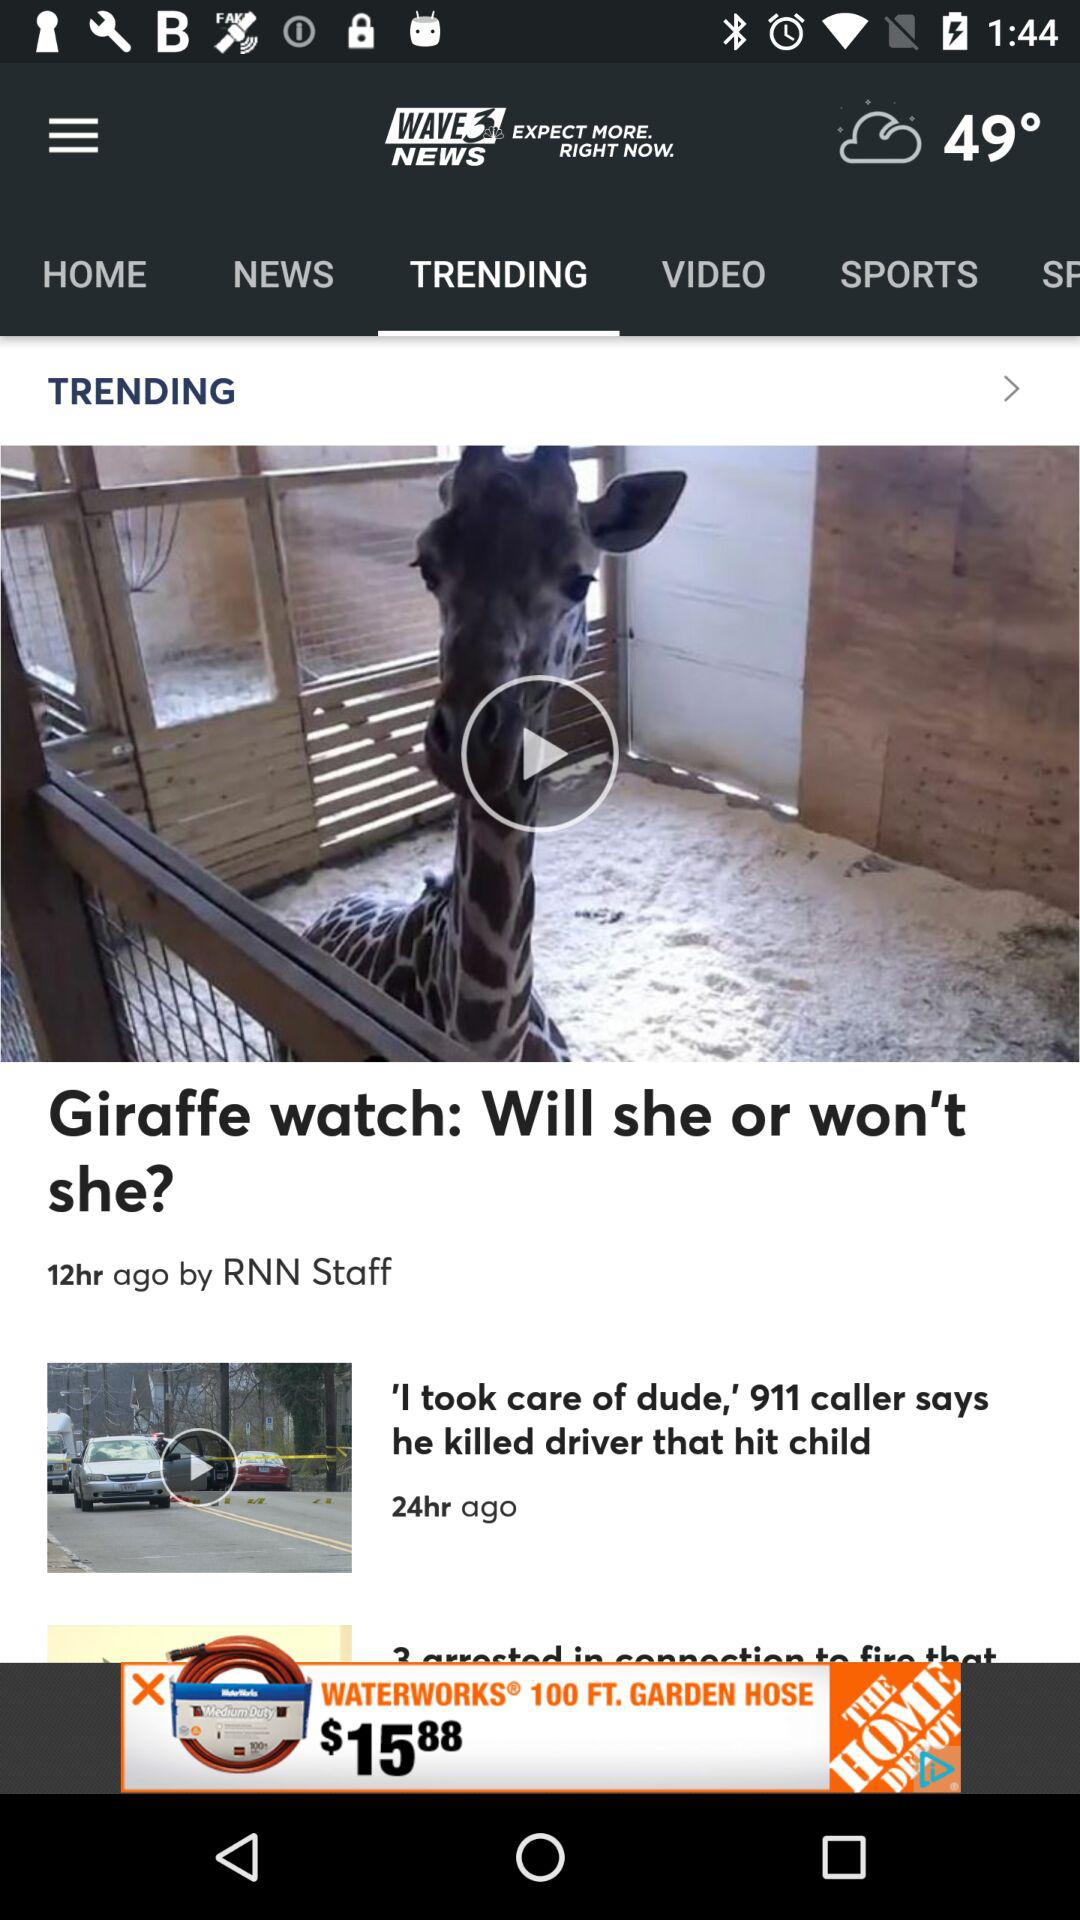How many hours ago was the trending video "Giraffe watch: Will she or won't she?" posted? The trending video "Giraffe watch: Will she or won't she?" was posted 12 hours ago. 